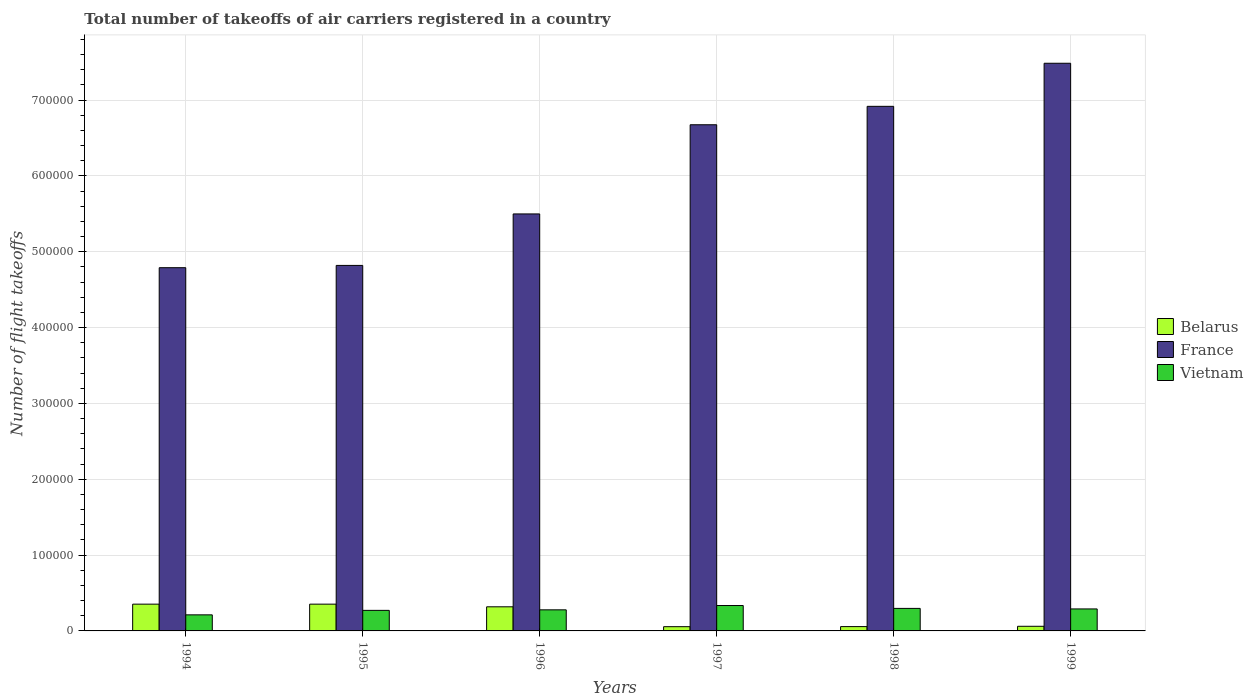How many different coloured bars are there?
Give a very brief answer. 3. How many groups of bars are there?
Make the answer very short. 6. Are the number of bars on each tick of the X-axis equal?
Offer a terse response. Yes. How many bars are there on the 2nd tick from the right?
Offer a terse response. 3. What is the total number of flight takeoffs in Belarus in 1994?
Provide a succinct answer. 3.53e+04. Across all years, what is the maximum total number of flight takeoffs in Vietnam?
Offer a terse response. 3.35e+04. Across all years, what is the minimum total number of flight takeoffs in Vietnam?
Your answer should be compact. 2.12e+04. In which year was the total number of flight takeoffs in France minimum?
Ensure brevity in your answer.  1994. What is the total total number of flight takeoffs in Belarus in the graph?
Keep it short and to the point. 1.20e+05. What is the difference between the total number of flight takeoffs in Vietnam in 1994 and that in 1996?
Give a very brief answer. -6600. What is the difference between the total number of flight takeoffs in Belarus in 1998 and the total number of flight takeoffs in France in 1994?
Provide a short and direct response. -4.73e+05. What is the average total number of flight takeoffs in France per year?
Provide a short and direct response. 6.03e+05. In the year 1998, what is the difference between the total number of flight takeoffs in Belarus and total number of flight takeoffs in France?
Your answer should be compact. -6.86e+05. What is the ratio of the total number of flight takeoffs in Vietnam in 1994 to that in 1998?
Offer a very short reply. 0.71. Is the total number of flight takeoffs in Belarus in 1995 less than that in 1997?
Make the answer very short. No. Is the difference between the total number of flight takeoffs in Belarus in 1994 and 1997 greater than the difference between the total number of flight takeoffs in France in 1994 and 1997?
Give a very brief answer. Yes. What is the difference between the highest and the second highest total number of flight takeoffs in Vietnam?
Give a very brief answer. 3800. What is the difference between the highest and the lowest total number of flight takeoffs in France?
Make the answer very short. 2.70e+05. In how many years, is the total number of flight takeoffs in Belarus greater than the average total number of flight takeoffs in Belarus taken over all years?
Offer a very short reply. 3. Is the sum of the total number of flight takeoffs in France in 1995 and 1998 greater than the maximum total number of flight takeoffs in Belarus across all years?
Keep it short and to the point. Yes. What does the 1st bar from the left in 1999 represents?
Give a very brief answer. Belarus. What does the 3rd bar from the right in 1994 represents?
Give a very brief answer. Belarus. Is it the case that in every year, the sum of the total number of flight takeoffs in Belarus and total number of flight takeoffs in Vietnam is greater than the total number of flight takeoffs in France?
Offer a terse response. No. Are all the bars in the graph horizontal?
Give a very brief answer. No. Are the values on the major ticks of Y-axis written in scientific E-notation?
Offer a terse response. No. Does the graph contain any zero values?
Your response must be concise. No. What is the title of the graph?
Keep it short and to the point. Total number of takeoffs of air carriers registered in a country. Does "Micronesia" appear as one of the legend labels in the graph?
Provide a short and direct response. No. What is the label or title of the X-axis?
Your response must be concise. Years. What is the label or title of the Y-axis?
Provide a short and direct response. Number of flight takeoffs. What is the Number of flight takeoffs of Belarus in 1994?
Provide a short and direct response. 3.53e+04. What is the Number of flight takeoffs in France in 1994?
Provide a short and direct response. 4.79e+05. What is the Number of flight takeoffs of Vietnam in 1994?
Offer a very short reply. 2.12e+04. What is the Number of flight takeoffs in Belarus in 1995?
Provide a succinct answer. 3.53e+04. What is the Number of flight takeoffs in France in 1995?
Provide a succinct answer. 4.82e+05. What is the Number of flight takeoffs of Vietnam in 1995?
Offer a terse response. 2.71e+04. What is the Number of flight takeoffs in Belarus in 1996?
Your answer should be compact. 3.18e+04. What is the Number of flight takeoffs of France in 1996?
Offer a terse response. 5.50e+05. What is the Number of flight takeoffs of Vietnam in 1996?
Make the answer very short. 2.78e+04. What is the Number of flight takeoffs of Belarus in 1997?
Make the answer very short. 5600. What is the Number of flight takeoffs of France in 1997?
Your response must be concise. 6.68e+05. What is the Number of flight takeoffs in Vietnam in 1997?
Offer a very short reply. 3.35e+04. What is the Number of flight takeoffs of Belarus in 1998?
Make the answer very short. 5700. What is the Number of flight takeoffs in France in 1998?
Give a very brief answer. 6.92e+05. What is the Number of flight takeoffs in Vietnam in 1998?
Offer a terse response. 2.97e+04. What is the Number of flight takeoffs in Belarus in 1999?
Offer a very short reply. 6100. What is the Number of flight takeoffs of France in 1999?
Provide a short and direct response. 7.49e+05. What is the Number of flight takeoffs in Vietnam in 1999?
Provide a short and direct response. 2.90e+04. Across all years, what is the maximum Number of flight takeoffs of Belarus?
Give a very brief answer. 3.53e+04. Across all years, what is the maximum Number of flight takeoffs of France?
Provide a short and direct response. 7.49e+05. Across all years, what is the maximum Number of flight takeoffs of Vietnam?
Your response must be concise. 3.35e+04. Across all years, what is the minimum Number of flight takeoffs of Belarus?
Your response must be concise. 5600. Across all years, what is the minimum Number of flight takeoffs of France?
Your response must be concise. 4.79e+05. Across all years, what is the minimum Number of flight takeoffs of Vietnam?
Offer a very short reply. 2.12e+04. What is the total Number of flight takeoffs of Belarus in the graph?
Provide a succinct answer. 1.20e+05. What is the total Number of flight takeoffs of France in the graph?
Ensure brevity in your answer.  3.62e+06. What is the total Number of flight takeoffs in Vietnam in the graph?
Offer a very short reply. 1.68e+05. What is the difference between the Number of flight takeoffs in France in 1994 and that in 1995?
Make the answer very short. -3000. What is the difference between the Number of flight takeoffs of Vietnam in 1994 and that in 1995?
Ensure brevity in your answer.  -5900. What is the difference between the Number of flight takeoffs of Belarus in 1994 and that in 1996?
Your answer should be very brief. 3500. What is the difference between the Number of flight takeoffs of France in 1994 and that in 1996?
Your answer should be very brief. -7.09e+04. What is the difference between the Number of flight takeoffs in Vietnam in 1994 and that in 1996?
Keep it short and to the point. -6600. What is the difference between the Number of flight takeoffs of Belarus in 1994 and that in 1997?
Offer a very short reply. 2.97e+04. What is the difference between the Number of flight takeoffs of France in 1994 and that in 1997?
Your response must be concise. -1.88e+05. What is the difference between the Number of flight takeoffs in Vietnam in 1994 and that in 1997?
Keep it short and to the point. -1.23e+04. What is the difference between the Number of flight takeoffs in Belarus in 1994 and that in 1998?
Offer a very short reply. 2.96e+04. What is the difference between the Number of flight takeoffs in France in 1994 and that in 1998?
Your answer should be compact. -2.13e+05. What is the difference between the Number of flight takeoffs in Vietnam in 1994 and that in 1998?
Give a very brief answer. -8500. What is the difference between the Number of flight takeoffs of Belarus in 1994 and that in 1999?
Offer a very short reply. 2.92e+04. What is the difference between the Number of flight takeoffs in France in 1994 and that in 1999?
Provide a succinct answer. -2.70e+05. What is the difference between the Number of flight takeoffs of Vietnam in 1994 and that in 1999?
Your answer should be compact. -7800. What is the difference between the Number of flight takeoffs of Belarus in 1995 and that in 1996?
Give a very brief answer. 3500. What is the difference between the Number of flight takeoffs in France in 1995 and that in 1996?
Offer a terse response. -6.79e+04. What is the difference between the Number of flight takeoffs in Vietnam in 1995 and that in 1996?
Your answer should be compact. -700. What is the difference between the Number of flight takeoffs in Belarus in 1995 and that in 1997?
Give a very brief answer. 2.97e+04. What is the difference between the Number of flight takeoffs of France in 1995 and that in 1997?
Keep it short and to the point. -1.86e+05. What is the difference between the Number of flight takeoffs in Vietnam in 1995 and that in 1997?
Give a very brief answer. -6400. What is the difference between the Number of flight takeoffs in Belarus in 1995 and that in 1998?
Your answer should be very brief. 2.96e+04. What is the difference between the Number of flight takeoffs in France in 1995 and that in 1998?
Offer a terse response. -2.10e+05. What is the difference between the Number of flight takeoffs of Vietnam in 1995 and that in 1998?
Make the answer very short. -2600. What is the difference between the Number of flight takeoffs in Belarus in 1995 and that in 1999?
Your response must be concise. 2.92e+04. What is the difference between the Number of flight takeoffs of France in 1995 and that in 1999?
Your response must be concise. -2.67e+05. What is the difference between the Number of flight takeoffs in Vietnam in 1995 and that in 1999?
Offer a very short reply. -1900. What is the difference between the Number of flight takeoffs of Belarus in 1996 and that in 1997?
Make the answer very short. 2.62e+04. What is the difference between the Number of flight takeoffs in France in 1996 and that in 1997?
Your response must be concise. -1.18e+05. What is the difference between the Number of flight takeoffs in Vietnam in 1996 and that in 1997?
Make the answer very short. -5700. What is the difference between the Number of flight takeoffs of Belarus in 1996 and that in 1998?
Keep it short and to the point. 2.61e+04. What is the difference between the Number of flight takeoffs of France in 1996 and that in 1998?
Your answer should be very brief. -1.42e+05. What is the difference between the Number of flight takeoffs in Vietnam in 1996 and that in 1998?
Offer a very short reply. -1900. What is the difference between the Number of flight takeoffs in Belarus in 1996 and that in 1999?
Provide a short and direct response. 2.57e+04. What is the difference between the Number of flight takeoffs of France in 1996 and that in 1999?
Offer a terse response. -1.99e+05. What is the difference between the Number of flight takeoffs of Vietnam in 1996 and that in 1999?
Offer a terse response. -1200. What is the difference between the Number of flight takeoffs in Belarus in 1997 and that in 1998?
Provide a succinct answer. -100. What is the difference between the Number of flight takeoffs in France in 1997 and that in 1998?
Give a very brief answer. -2.43e+04. What is the difference between the Number of flight takeoffs in Vietnam in 1997 and that in 1998?
Give a very brief answer. 3800. What is the difference between the Number of flight takeoffs in Belarus in 1997 and that in 1999?
Keep it short and to the point. -500. What is the difference between the Number of flight takeoffs in France in 1997 and that in 1999?
Make the answer very short. -8.11e+04. What is the difference between the Number of flight takeoffs in Vietnam in 1997 and that in 1999?
Your answer should be very brief. 4500. What is the difference between the Number of flight takeoffs of Belarus in 1998 and that in 1999?
Offer a terse response. -400. What is the difference between the Number of flight takeoffs of France in 1998 and that in 1999?
Your answer should be very brief. -5.68e+04. What is the difference between the Number of flight takeoffs of Vietnam in 1998 and that in 1999?
Provide a succinct answer. 700. What is the difference between the Number of flight takeoffs in Belarus in 1994 and the Number of flight takeoffs in France in 1995?
Offer a terse response. -4.47e+05. What is the difference between the Number of flight takeoffs of Belarus in 1994 and the Number of flight takeoffs of Vietnam in 1995?
Your response must be concise. 8200. What is the difference between the Number of flight takeoffs of France in 1994 and the Number of flight takeoffs of Vietnam in 1995?
Your answer should be compact. 4.52e+05. What is the difference between the Number of flight takeoffs of Belarus in 1994 and the Number of flight takeoffs of France in 1996?
Keep it short and to the point. -5.15e+05. What is the difference between the Number of flight takeoffs of Belarus in 1994 and the Number of flight takeoffs of Vietnam in 1996?
Make the answer very short. 7500. What is the difference between the Number of flight takeoffs of France in 1994 and the Number of flight takeoffs of Vietnam in 1996?
Provide a short and direct response. 4.51e+05. What is the difference between the Number of flight takeoffs of Belarus in 1994 and the Number of flight takeoffs of France in 1997?
Keep it short and to the point. -6.32e+05. What is the difference between the Number of flight takeoffs in Belarus in 1994 and the Number of flight takeoffs in Vietnam in 1997?
Offer a very short reply. 1800. What is the difference between the Number of flight takeoffs in France in 1994 and the Number of flight takeoffs in Vietnam in 1997?
Offer a terse response. 4.46e+05. What is the difference between the Number of flight takeoffs in Belarus in 1994 and the Number of flight takeoffs in France in 1998?
Provide a short and direct response. -6.56e+05. What is the difference between the Number of flight takeoffs in Belarus in 1994 and the Number of flight takeoffs in Vietnam in 1998?
Provide a short and direct response. 5600. What is the difference between the Number of flight takeoffs in France in 1994 and the Number of flight takeoffs in Vietnam in 1998?
Keep it short and to the point. 4.49e+05. What is the difference between the Number of flight takeoffs in Belarus in 1994 and the Number of flight takeoffs in France in 1999?
Offer a very short reply. -7.13e+05. What is the difference between the Number of flight takeoffs in Belarus in 1994 and the Number of flight takeoffs in Vietnam in 1999?
Ensure brevity in your answer.  6300. What is the difference between the Number of flight takeoffs in Belarus in 1995 and the Number of flight takeoffs in France in 1996?
Your answer should be compact. -5.15e+05. What is the difference between the Number of flight takeoffs of Belarus in 1995 and the Number of flight takeoffs of Vietnam in 1996?
Offer a very short reply. 7500. What is the difference between the Number of flight takeoffs in France in 1995 and the Number of flight takeoffs in Vietnam in 1996?
Keep it short and to the point. 4.54e+05. What is the difference between the Number of flight takeoffs in Belarus in 1995 and the Number of flight takeoffs in France in 1997?
Ensure brevity in your answer.  -6.32e+05. What is the difference between the Number of flight takeoffs in Belarus in 1995 and the Number of flight takeoffs in Vietnam in 1997?
Give a very brief answer. 1800. What is the difference between the Number of flight takeoffs in France in 1995 and the Number of flight takeoffs in Vietnam in 1997?
Make the answer very short. 4.48e+05. What is the difference between the Number of flight takeoffs in Belarus in 1995 and the Number of flight takeoffs in France in 1998?
Your answer should be compact. -6.56e+05. What is the difference between the Number of flight takeoffs in Belarus in 1995 and the Number of flight takeoffs in Vietnam in 1998?
Ensure brevity in your answer.  5600. What is the difference between the Number of flight takeoffs in France in 1995 and the Number of flight takeoffs in Vietnam in 1998?
Offer a terse response. 4.52e+05. What is the difference between the Number of flight takeoffs of Belarus in 1995 and the Number of flight takeoffs of France in 1999?
Ensure brevity in your answer.  -7.13e+05. What is the difference between the Number of flight takeoffs of Belarus in 1995 and the Number of flight takeoffs of Vietnam in 1999?
Your response must be concise. 6300. What is the difference between the Number of flight takeoffs in France in 1995 and the Number of flight takeoffs in Vietnam in 1999?
Give a very brief answer. 4.53e+05. What is the difference between the Number of flight takeoffs of Belarus in 1996 and the Number of flight takeoffs of France in 1997?
Provide a succinct answer. -6.36e+05. What is the difference between the Number of flight takeoffs of Belarus in 1996 and the Number of flight takeoffs of Vietnam in 1997?
Give a very brief answer. -1700. What is the difference between the Number of flight takeoffs of France in 1996 and the Number of flight takeoffs of Vietnam in 1997?
Your answer should be very brief. 5.16e+05. What is the difference between the Number of flight takeoffs of Belarus in 1996 and the Number of flight takeoffs of France in 1998?
Your answer should be very brief. -6.60e+05. What is the difference between the Number of flight takeoffs of Belarus in 1996 and the Number of flight takeoffs of Vietnam in 1998?
Make the answer very short. 2100. What is the difference between the Number of flight takeoffs in France in 1996 and the Number of flight takeoffs in Vietnam in 1998?
Make the answer very short. 5.20e+05. What is the difference between the Number of flight takeoffs in Belarus in 1996 and the Number of flight takeoffs in France in 1999?
Provide a succinct answer. -7.17e+05. What is the difference between the Number of flight takeoffs in Belarus in 1996 and the Number of flight takeoffs in Vietnam in 1999?
Provide a succinct answer. 2800. What is the difference between the Number of flight takeoffs in France in 1996 and the Number of flight takeoffs in Vietnam in 1999?
Provide a succinct answer. 5.21e+05. What is the difference between the Number of flight takeoffs in Belarus in 1997 and the Number of flight takeoffs in France in 1998?
Ensure brevity in your answer.  -6.86e+05. What is the difference between the Number of flight takeoffs in Belarus in 1997 and the Number of flight takeoffs in Vietnam in 1998?
Provide a short and direct response. -2.41e+04. What is the difference between the Number of flight takeoffs in France in 1997 and the Number of flight takeoffs in Vietnam in 1998?
Your response must be concise. 6.38e+05. What is the difference between the Number of flight takeoffs of Belarus in 1997 and the Number of flight takeoffs of France in 1999?
Your response must be concise. -7.43e+05. What is the difference between the Number of flight takeoffs of Belarus in 1997 and the Number of flight takeoffs of Vietnam in 1999?
Your answer should be very brief. -2.34e+04. What is the difference between the Number of flight takeoffs of France in 1997 and the Number of flight takeoffs of Vietnam in 1999?
Provide a short and direct response. 6.38e+05. What is the difference between the Number of flight takeoffs in Belarus in 1998 and the Number of flight takeoffs in France in 1999?
Provide a short and direct response. -7.43e+05. What is the difference between the Number of flight takeoffs in Belarus in 1998 and the Number of flight takeoffs in Vietnam in 1999?
Offer a very short reply. -2.33e+04. What is the difference between the Number of flight takeoffs of France in 1998 and the Number of flight takeoffs of Vietnam in 1999?
Offer a very short reply. 6.63e+05. What is the average Number of flight takeoffs in Belarus per year?
Give a very brief answer. 2.00e+04. What is the average Number of flight takeoffs in France per year?
Offer a terse response. 6.03e+05. What is the average Number of flight takeoffs in Vietnam per year?
Provide a short and direct response. 2.80e+04. In the year 1994, what is the difference between the Number of flight takeoffs in Belarus and Number of flight takeoffs in France?
Your response must be concise. -4.44e+05. In the year 1994, what is the difference between the Number of flight takeoffs in Belarus and Number of flight takeoffs in Vietnam?
Your answer should be compact. 1.41e+04. In the year 1994, what is the difference between the Number of flight takeoffs in France and Number of flight takeoffs in Vietnam?
Offer a very short reply. 4.58e+05. In the year 1995, what is the difference between the Number of flight takeoffs of Belarus and Number of flight takeoffs of France?
Give a very brief answer. -4.47e+05. In the year 1995, what is the difference between the Number of flight takeoffs of Belarus and Number of flight takeoffs of Vietnam?
Your answer should be compact. 8200. In the year 1995, what is the difference between the Number of flight takeoffs in France and Number of flight takeoffs in Vietnam?
Give a very brief answer. 4.55e+05. In the year 1996, what is the difference between the Number of flight takeoffs of Belarus and Number of flight takeoffs of France?
Offer a terse response. -5.18e+05. In the year 1996, what is the difference between the Number of flight takeoffs of Belarus and Number of flight takeoffs of Vietnam?
Your response must be concise. 4000. In the year 1996, what is the difference between the Number of flight takeoffs in France and Number of flight takeoffs in Vietnam?
Keep it short and to the point. 5.22e+05. In the year 1997, what is the difference between the Number of flight takeoffs in Belarus and Number of flight takeoffs in France?
Provide a succinct answer. -6.62e+05. In the year 1997, what is the difference between the Number of flight takeoffs in Belarus and Number of flight takeoffs in Vietnam?
Make the answer very short. -2.79e+04. In the year 1997, what is the difference between the Number of flight takeoffs in France and Number of flight takeoffs in Vietnam?
Offer a very short reply. 6.34e+05. In the year 1998, what is the difference between the Number of flight takeoffs in Belarus and Number of flight takeoffs in France?
Give a very brief answer. -6.86e+05. In the year 1998, what is the difference between the Number of flight takeoffs of Belarus and Number of flight takeoffs of Vietnam?
Keep it short and to the point. -2.40e+04. In the year 1998, what is the difference between the Number of flight takeoffs in France and Number of flight takeoffs in Vietnam?
Offer a terse response. 6.62e+05. In the year 1999, what is the difference between the Number of flight takeoffs of Belarus and Number of flight takeoffs of France?
Your answer should be very brief. -7.42e+05. In the year 1999, what is the difference between the Number of flight takeoffs in Belarus and Number of flight takeoffs in Vietnam?
Provide a short and direct response. -2.29e+04. In the year 1999, what is the difference between the Number of flight takeoffs in France and Number of flight takeoffs in Vietnam?
Your answer should be very brief. 7.20e+05. What is the ratio of the Number of flight takeoffs in Vietnam in 1994 to that in 1995?
Keep it short and to the point. 0.78. What is the ratio of the Number of flight takeoffs in Belarus in 1994 to that in 1996?
Offer a terse response. 1.11. What is the ratio of the Number of flight takeoffs of France in 1994 to that in 1996?
Give a very brief answer. 0.87. What is the ratio of the Number of flight takeoffs in Vietnam in 1994 to that in 1996?
Ensure brevity in your answer.  0.76. What is the ratio of the Number of flight takeoffs of Belarus in 1994 to that in 1997?
Make the answer very short. 6.3. What is the ratio of the Number of flight takeoffs in France in 1994 to that in 1997?
Make the answer very short. 0.72. What is the ratio of the Number of flight takeoffs of Vietnam in 1994 to that in 1997?
Give a very brief answer. 0.63. What is the ratio of the Number of flight takeoffs in Belarus in 1994 to that in 1998?
Your answer should be compact. 6.19. What is the ratio of the Number of flight takeoffs of France in 1994 to that in 1998?
Make the answer very short. 0.69. What is the ratio of the Number of flight takeoffs of Vietnam in 1994 to that in 1998?
Your answer should be compact. 0.71. What is the ratio of the Number of flight takeoffs of Belarus in 1994 to that in 1999?
Your response must be concise. 5.79. What is the ratio of the Number of flight takeoffs in France in 1994 to that in 1999?
Your answer should be very brief. 0.64. What is the ratio of the Number of flight takeoffs of Vietnam in 1994 to that in 1999?
Give a very brief answer. 0.73. What is the ratio of the Number of flight takeoffs of Belarus in 1995 to that in 1996?
Make the answer very short. 1.11. What is the ratio of the Number of flight takeoffs of France in 1995 to that in 1996?
Your answer should be compact. 0.88. What is the ratio of the Number of flight takeoffs of Vietnam in 1995 to that in 1996?
Ensure brevity in your answer.  0.97. What is the ratio of the Number of flight takeoffs of Belarus in 1995 to that in 1997?
Ensure brevity in your answer.  6.3. What is the ratio of the Number of flight takeoffs in France in 1995 to that in 1997?
Provide a short and direct response. 0.72. What is the ratio of the Number of flight takeoffs of Vietnam in 1995 to that in 1997?
Keep it short and to the point. 0.81. What is the ratio of the Number of flight takeoffs in Belarus in 1995 to that in 1998?
Offer a very short reply. 6.19. What is the ratio of the Number of flight takeoffs in France in 1995 to that in 1998?
Offer a very short reply. 0.7. What is the ratio of the Number of flight takeoffs of Vietnam in 1995 to that in 1998?
Your answer should be very brief. 0.91. What is the ratio of the Number of flight takeoffs of Belarus in 1995 to that in 1999?
Make the answer very short. 5.79. What is the ratio of the Number of flight takeoffs in France in 1995 to that in 1999?
Your answer should be very brief. 0.64. What is the ratio of the Number of flight takeoffs of Vietnam in 1995 to that in 1999?
Keep it short and to the point. 0.93. What is the ratio of the Number of flight takeoffs of Belarus in 1996 to that in 1997?
Provide a short and direct response. 5.68. What is the ratio of the Number of flight takeoffs in France in 1996 to that in 1997?
Your answer should be compact. 0.82. What is the ratio of the Number of flight takeoffs in Vietnam in 1996 to that in 1997?
Ensure brevity in your answer.  0.83. What is the ratio of the Number of flight takeoffs in Belarus in 1996 to that in 1998?
Ensure brevity in your answer.  5.58. What is the ratio of the Number of flight takeoffs in France in 1996 to that in 1998?
Offer a very short reply. 0.79. What is the ratio of the Number of flight takeoffs in Vietnam in 1996 to that in 1998?
Your answer should be very brief. 0.94. What is the ratio of the Number of flight takeoffs in Belarus in 1996 to that in 1999?
Your response must be concise. 5.21. What is the ratio of the Number of flight takeoffs in France in 1996 to that in 1999?
Provide a succinct answer. 0.73. What is the ratio of the Number of flight takeoffs of Vietnam in 1996 to that in 1999?
Offer a very short reply. 0.96. What is the ratio of the Number of flight takeoffs of Belarus in 1997 to that in 1998?
Keep it short and to the point. 0.98. What is the ratio of the Number of flight takeoffs in France in 1997 to that in 1998?
Ensure brevity in your answer.  0.96. What is the ratio of the Number of flight takeoffs in Vietnam in 1997 to that in 1998?
Your answer should be compact. 1.13. What is the ratio of the Number of flight takeoffs of Belarus in 1997 to that in 1999?
Your answer should be very brief. 0.92. What is the ratio of the Number of flight takeoffs of France in 1997 to that in 1999?
Offer a terse response. 0.89. What is the ratio of the Number of flight takeoffs in Vietnam in 1997 to that in 1999?
Give a very brief answer. 1.16. What is the ratio of the Number of flight takeoffs of Belarus in 1998 to that in 1999?
Offer a terse response. 0.93. What is the ratio of the Number of flight takeoffs of France in 1998 to that in 1999?
Offer a terse response. 0.92. What is the ratio of the Number of flight takeoffs in Vietnam in 1998 to that in 1999?
Offer a very short reply. 1.02. What is the difference between the highest and the second highest Number of flight takeoffs of Belarus?
Your answer should be compact. 0. What is the difference between the highest and the second highest Number of flight takeoffs in France?
Make the answer very short. 5.68e+04. What is the difference between the highest and the second highest Number of flight takeoffs in Vietnam?
Your answer should be compact. 3800. What is the difference between the highest and the lowest Number of flight takeoffs of Belarus?
Offer a terse response. 2.97e+04. What is the difference between the highest and the lowest Number of flight takeoffs of France?
Keep it short and to the point. 2.70e+05. What is the difference between the highest and the lowest Number of flight takeoffs in Vietnam?
Offer a terse response. 1.23e+04. 